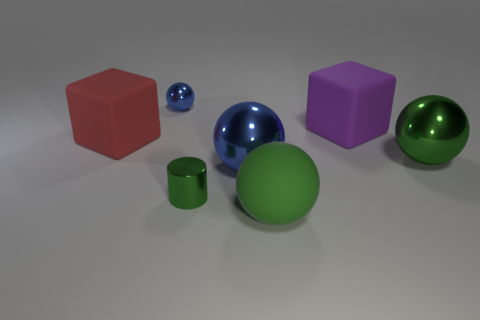There is a tiny cylinder; is its color the same as the sphere that is right of the big purple rubber object?
Provide a short and direct response. Yes. There is another big ball that is the same color as the rubber sphere; what is its material?
Offer a terse response. Metal. The purple matte thing has what size?
Ensure brevity in your answer.  Large. How many large things are either metal objects or red rubber objects?
Your answer should be very brief. 3. There is a green rubber ball; does it have the same size as the cylinder left of the large purple object?
Your answer should be very brief. No. Is there any other thing that is the same shape as the small green metallic thing?
Offer a terse response. No. How many small things are there?
Make the answer very short. 2. What number of cyan objects are either small things or big rubber cubes?
Give a very brief answer. 0. Is the green sphere in front of the large green metal object made of the same material as the large red block?
Offer a very short reply. Yes. What number of other things are there of the same material as the cylinder
Provide a succinct answer. 3. 